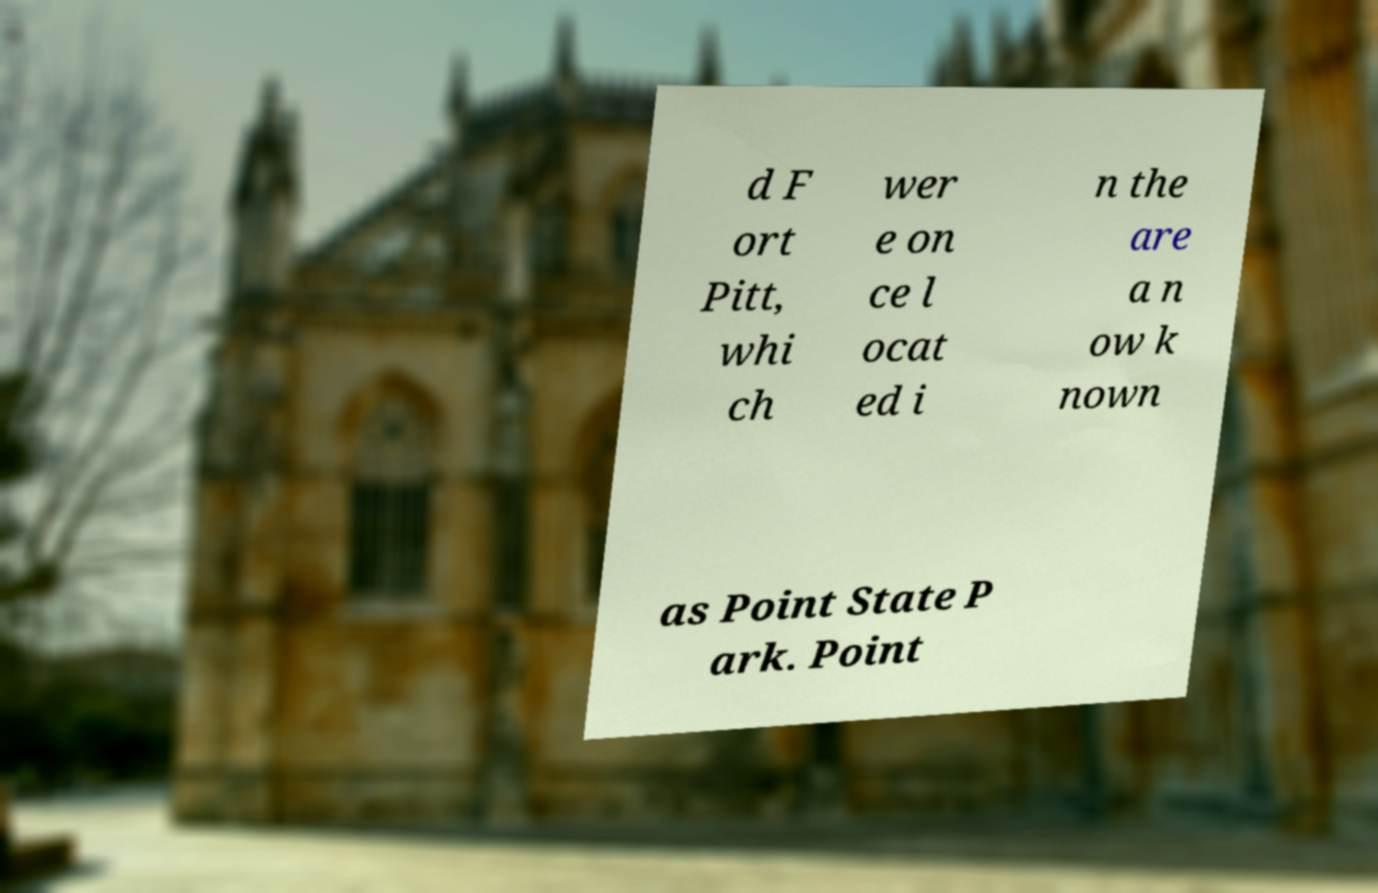Can you read and provide the text displayed in the image?This photo seems to have some interesting text. Can you extract and type it out for me? d F ort Pitt, whi ch wer e on ce l ocat ed i n the are a n ow k nown as Point State P ark. Point 